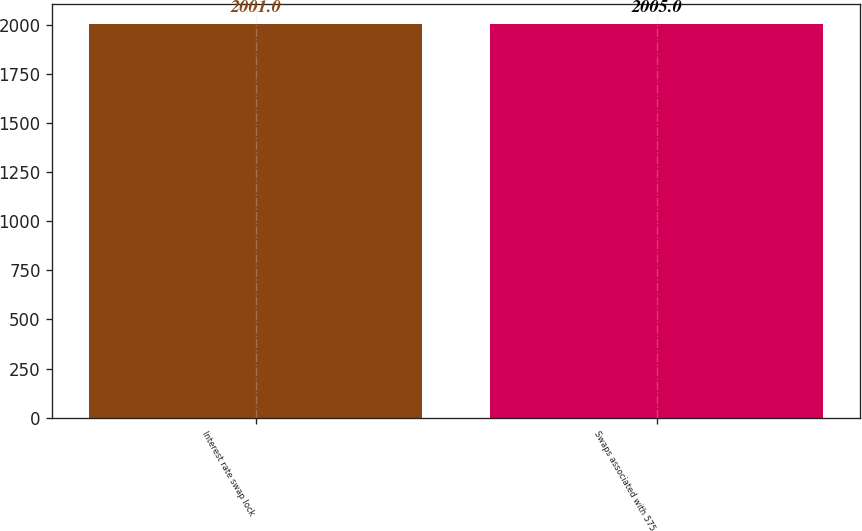Convert chart to OTSL. <chart><loc_0><loc_0><loc_500><loc_500><bar_chart><fcel>Interest rate swap lock<fcel>Swaps associated with 575<nl><fcel>2001<fcel>2005<nl></chart> 